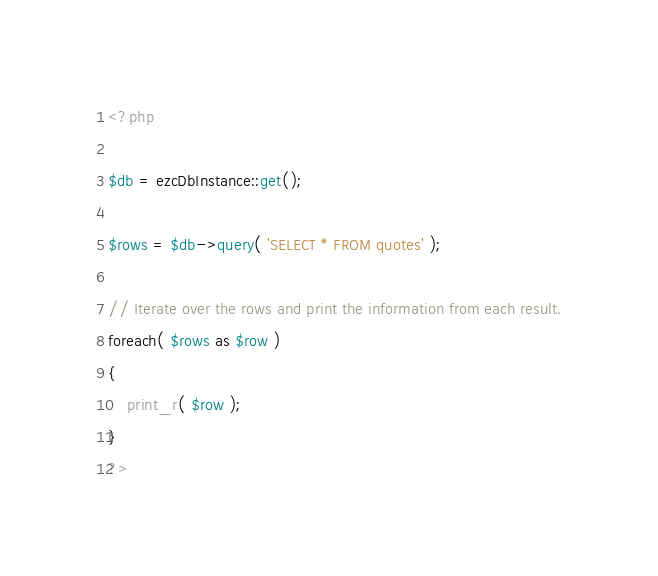Convert code to text. <code><loc_0><loc_0><loc_500><loc_500><_PHP_><?php

$db = ezcDbInstance::get();

$rows = $db->query( 'SELECT * FROM quotes' );

// Iterate over the rows and print the information from each result.
foreach( $rows as $row )
{
    print_r( $row );
}
?>
</code> 